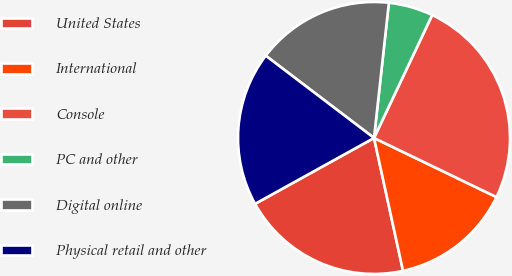Convert chart. <chart><loc_0><loc_0><loc_500><loc_500><pie_chart><fcel>United States<fcel>International<fcel>Console<fcel>PC and other<fcel>Digital online<fcel>Physical retail and other<nl><fcel>20.37%<fcel>14.42%<fcel>25.13%<fcel>5.29%<fcel>16.4%<fcel>18.39%<nl></chart> 